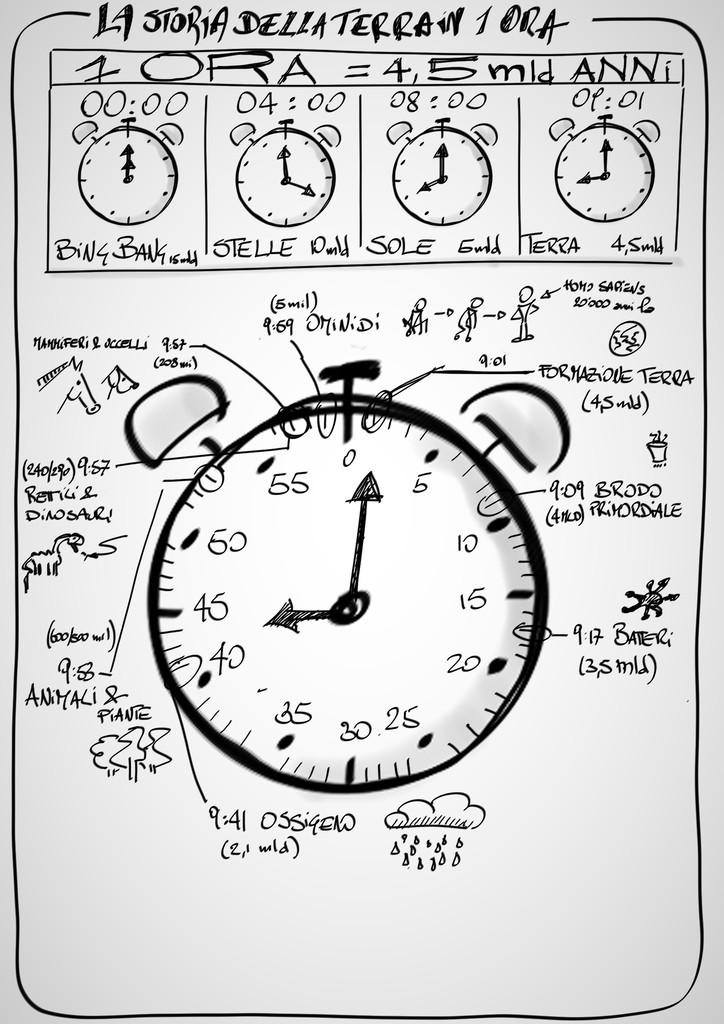Provide a one-sentence caption for the provided image. La Storia Della Terrain 1 Ora paints a narrative with many clocks. 